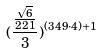Convert formula to latex. <formula><loc_0><loc_0><loc_500><loc_500>( \frac { \frac { \sqrt { 6 } } { 2 2 1 } } { 3 } ) ^ { ( 3 4 9 \cdot 4 ) + 1 }</formula> 